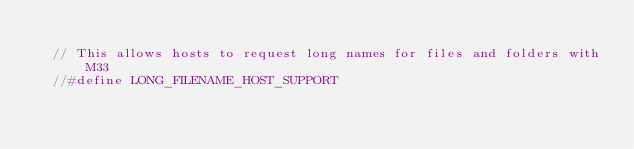<code> <loc_0><loc_0><loc_500><loc_500><_C_>
  // This allows hosts to request long names for files and folders with M33
  //#define LONG_FILENAME_HOST_SUPPORT
</code> 